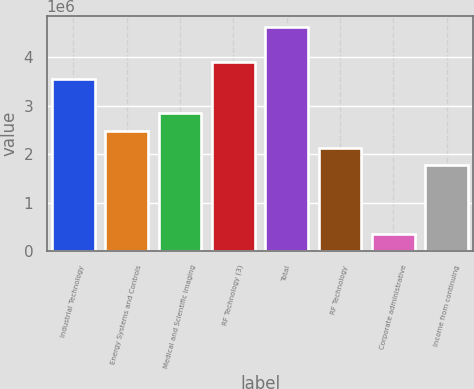Convert chart. <chart><loc_0><loc_0><loc_500><loc_500><bar_chart><fcel>Industrial Technology<fcel>Energy Systems and Controls<fcel>Medical and Scientific Imaging<fcel>RF Technology (3)<fcel>Total<fcel>RF Technology<fcel>Corporate administrative<fcel>Income from continuing<nl><fcel>3.54949e+06<fcel>2.48465e+06<fcel>2.8396e+06<fcel>3.90444e+06<fcel>4.61434e+06<fcel>2.1297e+06<fcel>354951<fcel>1.77475e+06<nl></chart> 